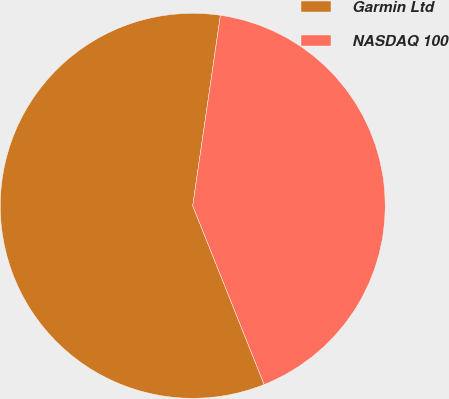Convert chart to OTSL. <chart><loc_0><loc_0><loc_500><loc_500><pie_chart><fcel>Garmin Ltd<fcel>NASDAQ 100<nl><fcel>58.35%<fcel>41.65%<nl></chart> 